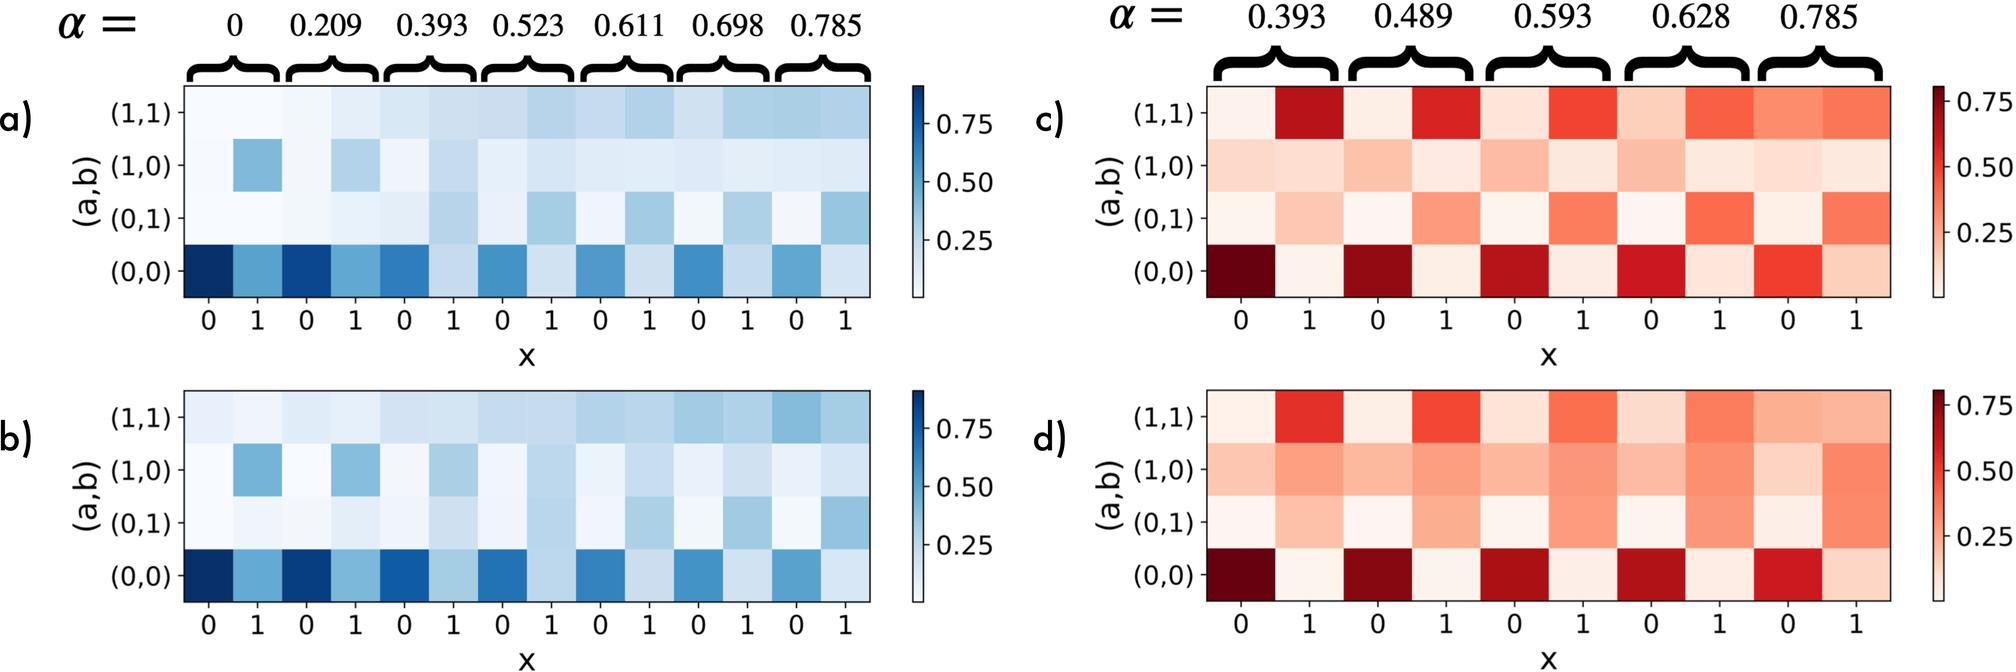Which figure set shows a higher maximum correlation value between (a,b) when 'x' equals 1? A. Figures a and b B. Figures c and d C. Both sets show equal correlation values. D. The figures do not provide information about specific values of 'x'. At 'x' equals 1, the color intensity in figures c and d is darker than in figures a and b, indicating a higher correlation value. Therefore, the correct answer is B. 